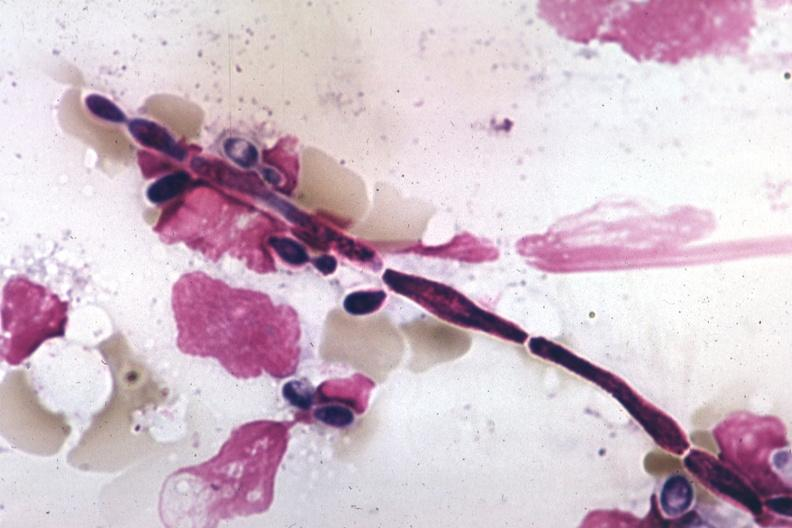what is present?
Answer the question using a single word or phrase. Hematologic 